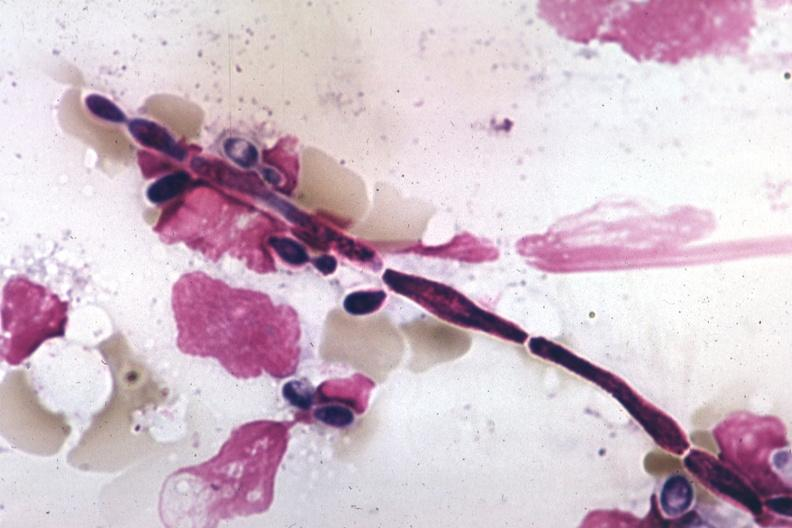what is present?
Answer the question using a single word or phrase. Hematologic 